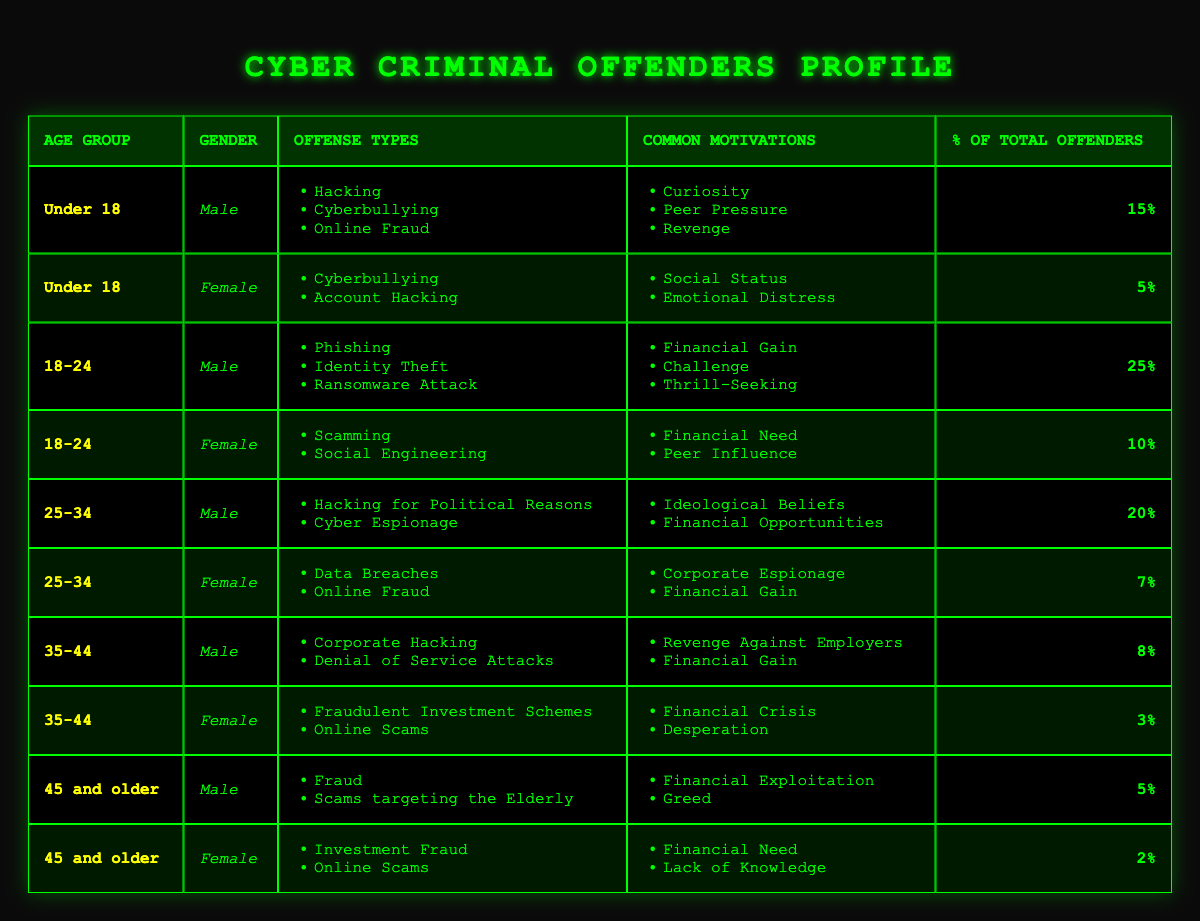What is the most common age group for male cyber criminals? The table shows that the age group "18-24" has the highest percentage of male offenders at 25%. Other age groups have lower percentages (Under 18: 15%, 25-34: 20%, 35-44: 8%, 45 and older: 5%). Thus, the answer focuses on the highest value found.
Answer: 18-24 What types of offenses are committed by females aged 35-44? For females aged 35-44, the offenses listed are "Fraudulent Investment Schemes" and "Online Scams." These offense types are taken directly from the corresponding row for that age and gender.
Answer: Fraudulent Investment Schemes, Online Scams What is the total percentage of offenders for the age group 25-34? The table lists male offenders aged 25-34 with a percentage of 20% and female offenders with a percentage of 7%. To find the total, we add these two percentages: 20% + 7% = 27%.
Answer: 27% Are there any cyber criminals over 45 who commit online scams? Yes, the table indicates that females aged 45 and older commit "Online Scams." This is found by looking for the "Online Scams" offense under the age group "45 and older."
Answer: Yes What is the average percentage of total offenders for males across all age groups? The percentages for male offenders are 15% (Under 18), 25% (18-24), 20% (25-34), 8% (35-44), and 5% (45 and older). Adding these gives 15 + 25 + 20 + 8 + 5 = 73%. Since there are 5 age categories, calculate the average: 73% / 5 = 14.6%.
Answer: 14.6% Which age group has the lowest percentage of female offenders? The table shows the following percentages for females: Under 18 (5%), 18-24 (10%), 25-34 (7%), 35-44 (3%), and 45 and older (2%). The lowest percentage is 2%, corresponding to the age group "45 and older."
Answer: 45 and older What are the common motivations for male offenders aged 18-24? The table lists the common motivations for male offenders aged 18-24 as "Financial Gain," "Challenge," and "Thrill-Seeking." These are found in the corresponding row under the motivations column for that age and gender.
Answer: Financial Gain, Challenge, Thrill-Seeking How many offense types are listed for male offenders in the age group Under 18? The table indicates three offense types for male offenders aged Under 18: "Hacking," "Cyberbullying," and "Online Fraud." The number of offense types is counted directly from the corresponding row.
Answer: 3 What is the most common motivation for female cyber criminals? The table shows that for females in all age groups, motivations vary but "Financial Need" from the 18-24 age group is prominent. However, the most frequently repeated motivation across age groups pertains to some level of financial gain or crisis. Thus, analyzing motivational patterns suggests that "Financial Gain" appears in several groups, making it a common factor.
Answer: Financial Gain 